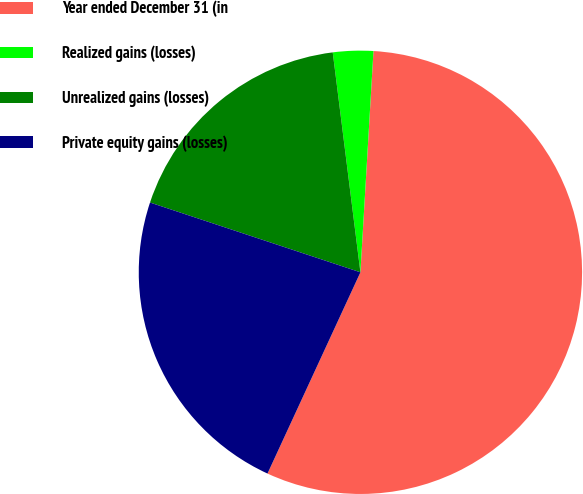Convert chart to OTSL. <chart><loc_0><loc_0><loc_500><loc_500><pie_chart><fcel>Year ended December 31 (in<fcel>Realized gains (losses)<fcel>Unrealized gains (losses)<fcel>Private equity gains (losses)<nl><fcel>55.94%<fcel>2.93%<fcel>17.91%<fcel>23.21%<nl></chart> 